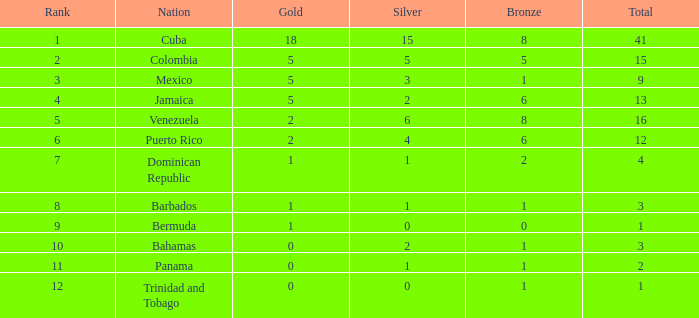Which is the highest-ranking bronze with a rank greater than 1, belonging to the dominican republic, and having a total exceeding 4? None. 